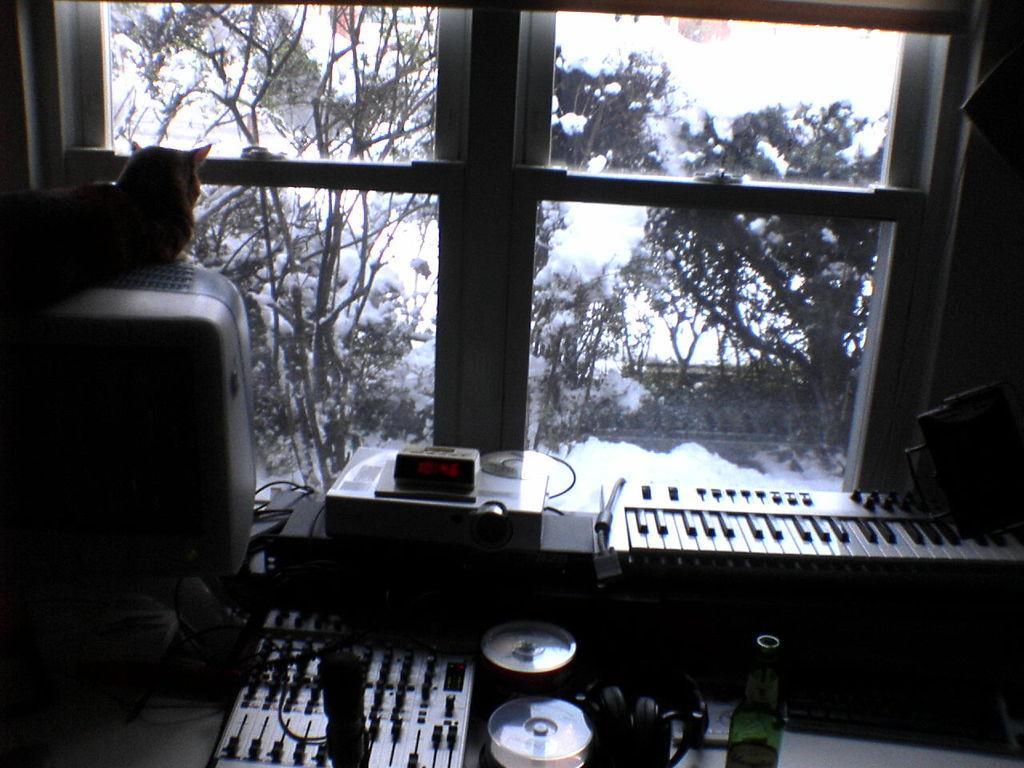Please provide a concise description of this image. In the foreground I can see a table, bottle, musical instruments and a cat is sitting on a machine. In the background I can see a window and trees. This image is taken may be in a room. 